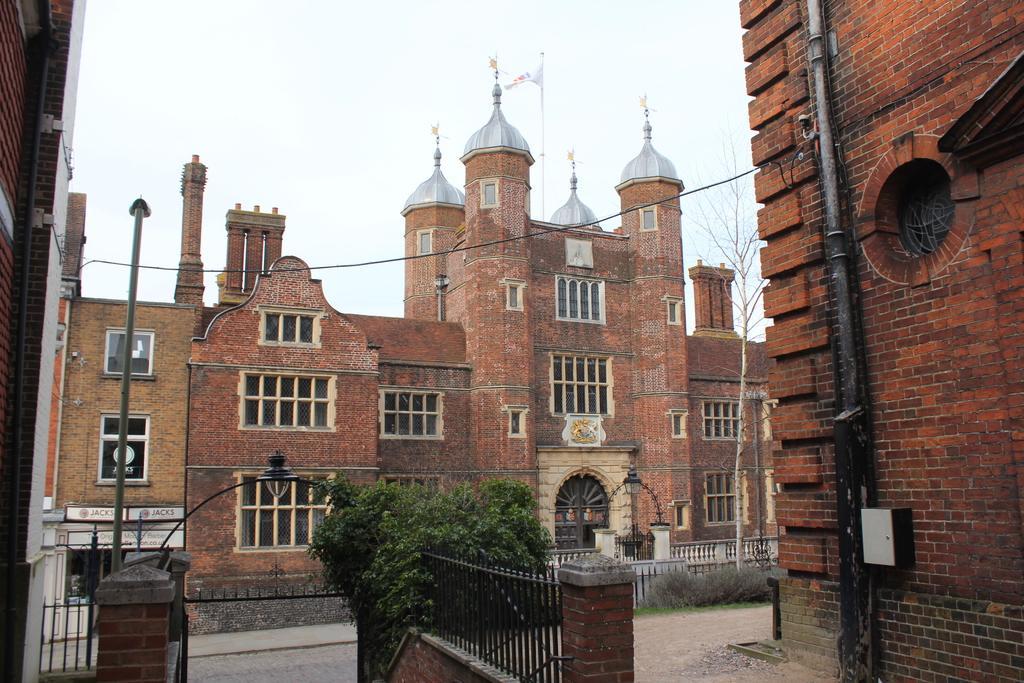How would you summarize this image in a sentence or two? In the picture I can see gate, fencing, compound wall, plants and in the background of the picture there is a building, top of the building there is a flag and top of the picture there is clear sky. 